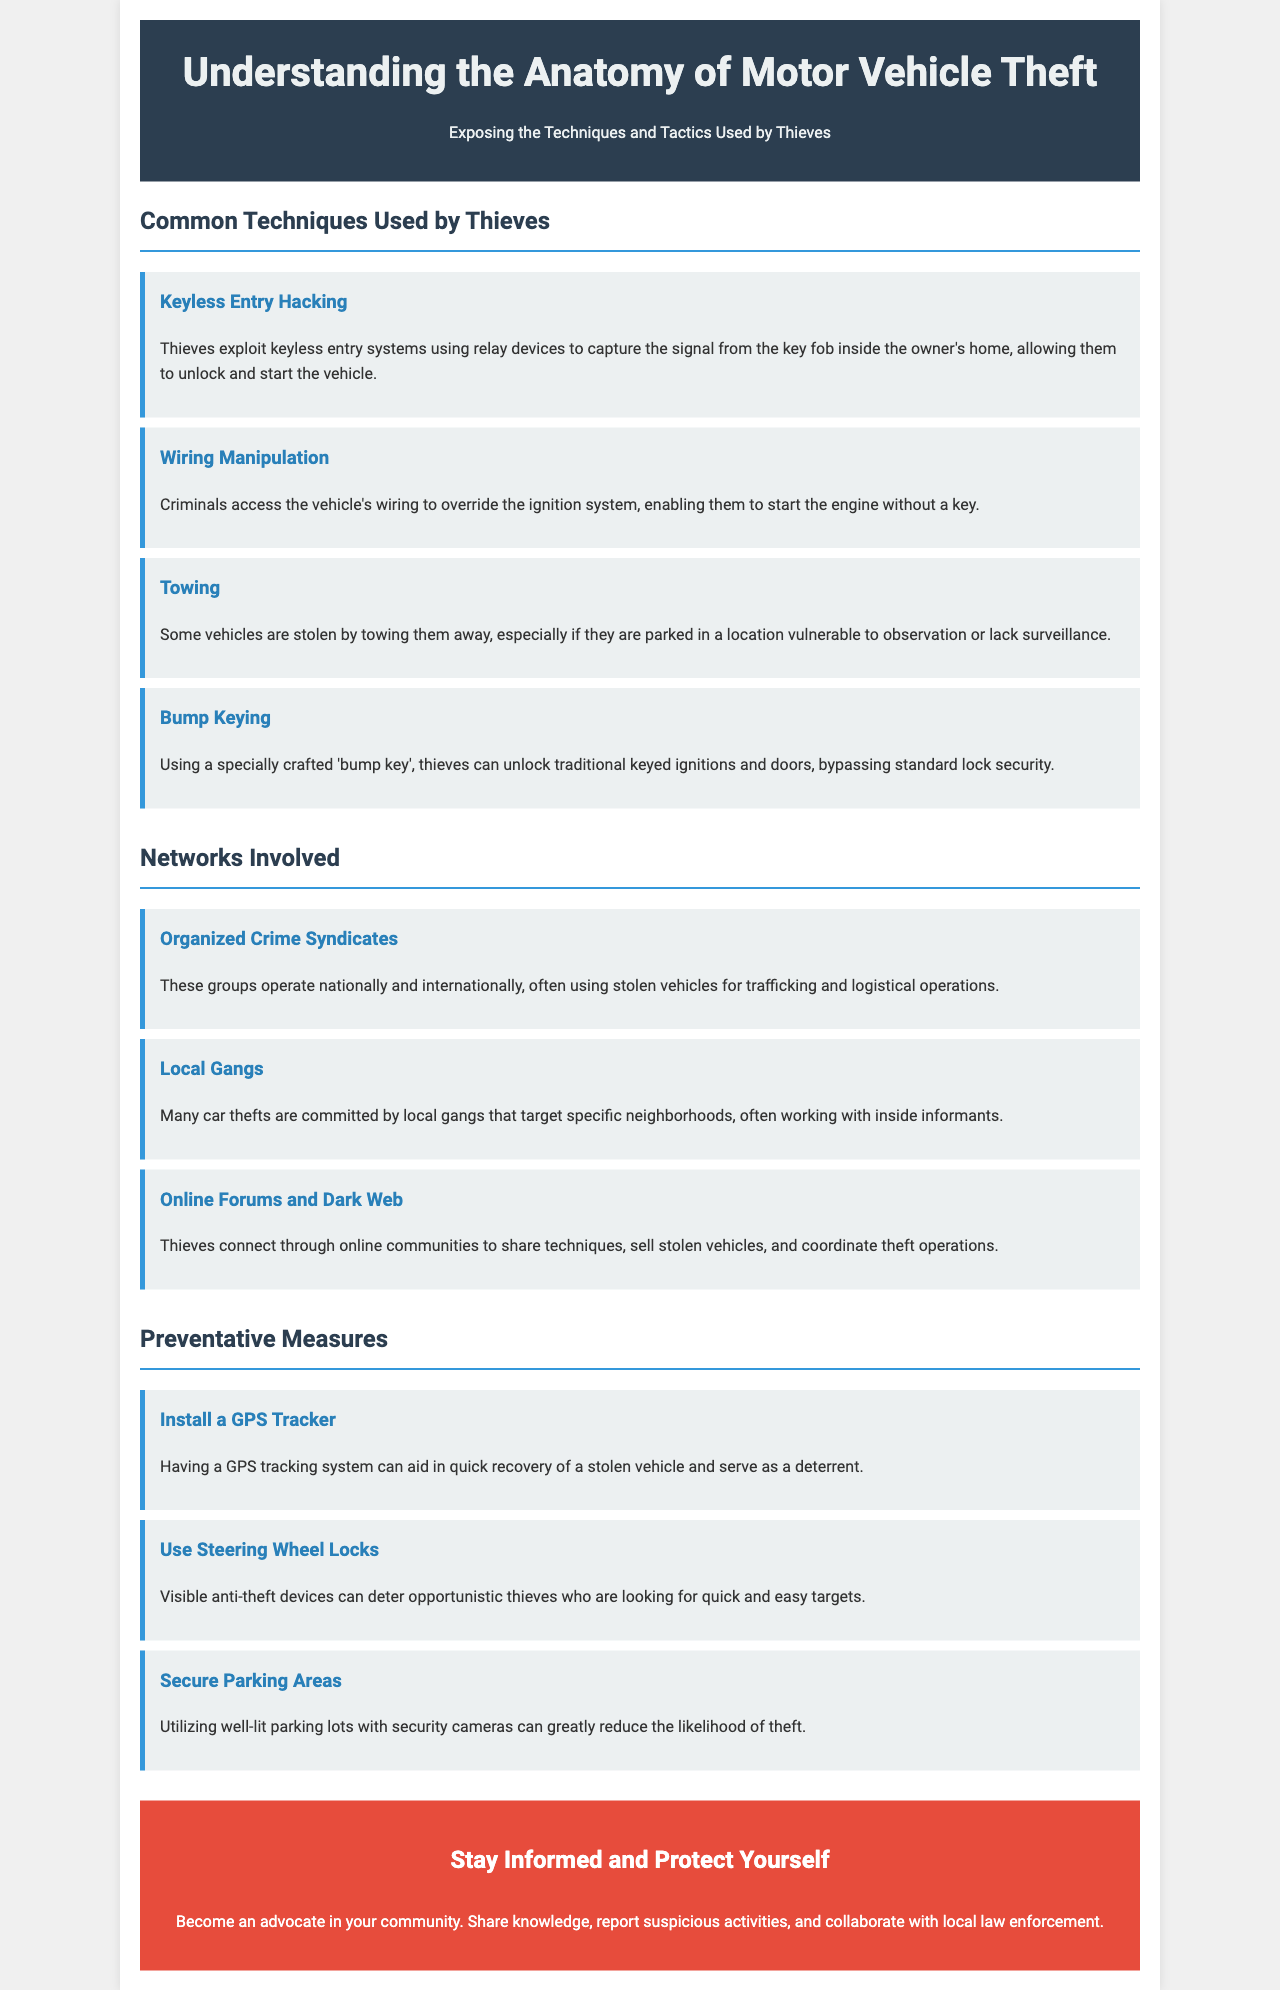what is the title of the brochure? The title of the brochure is stated at the top of the document.
Answer: Understanding the Anatomy of Motor Vehicle Theft how many common techniques are listed in the document? The document outlines a total of four techniques under the section "Common Techniques Used by Thieves."
Answer: 4 what is the first technique mentioned for vehicle theft? The document provides a structured list starting with the first technique under "Common Techniques."
Answer: Keyless Entry Hacking which group operates nationally and internationally? This question refers to the networks involved in motor vehicle theft.
Answer: Organized Crime Syndicates what preventative measure involves a visible anti-theft device? The document lists several measures, emphasizing a specific method aimed at deterring theft.
Answer: Use Steering Wheel Locks what type of online platform do thieves use to coordinate theft operations? This question highlights the role of technology in facilitating motor vehicle theft networks.
Answer: Dark Web which preventative measure aids in quick recovery of a stolen vehicle? The document mentions measures that help protect against theft and assist in recovery.
Answer: Install a GPS Tracker how does the brochure encourage community involvement? The call-to-action section emphasizes a specific action to motivate community engagement.
Answer: Share knowledge, report suspicious activities what color is used for the section headers in the document? The document's design includes specific colors for visual distinction in the headers.
Answer: #2c3e50 